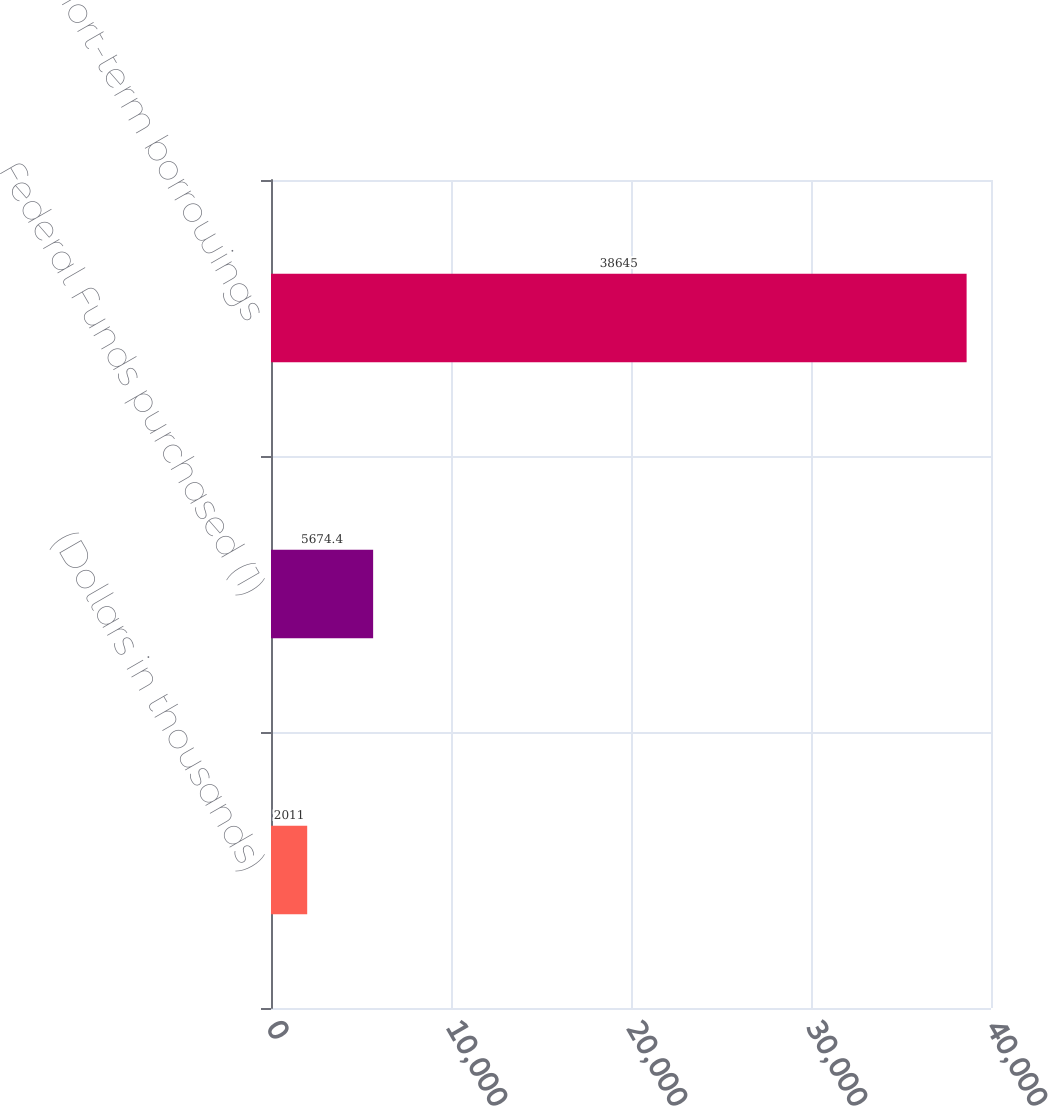Convert chart. <chart><loc_0><loc_0><loc_500><loc_500><bar_chart><fcel>(Dollars in thousands)<fcel>Federal Funds purchased (1)<fcel>Other short-term borrowings<nl><fcel>2011<fcel>5674.4<fcel>38645<nl></chart> 